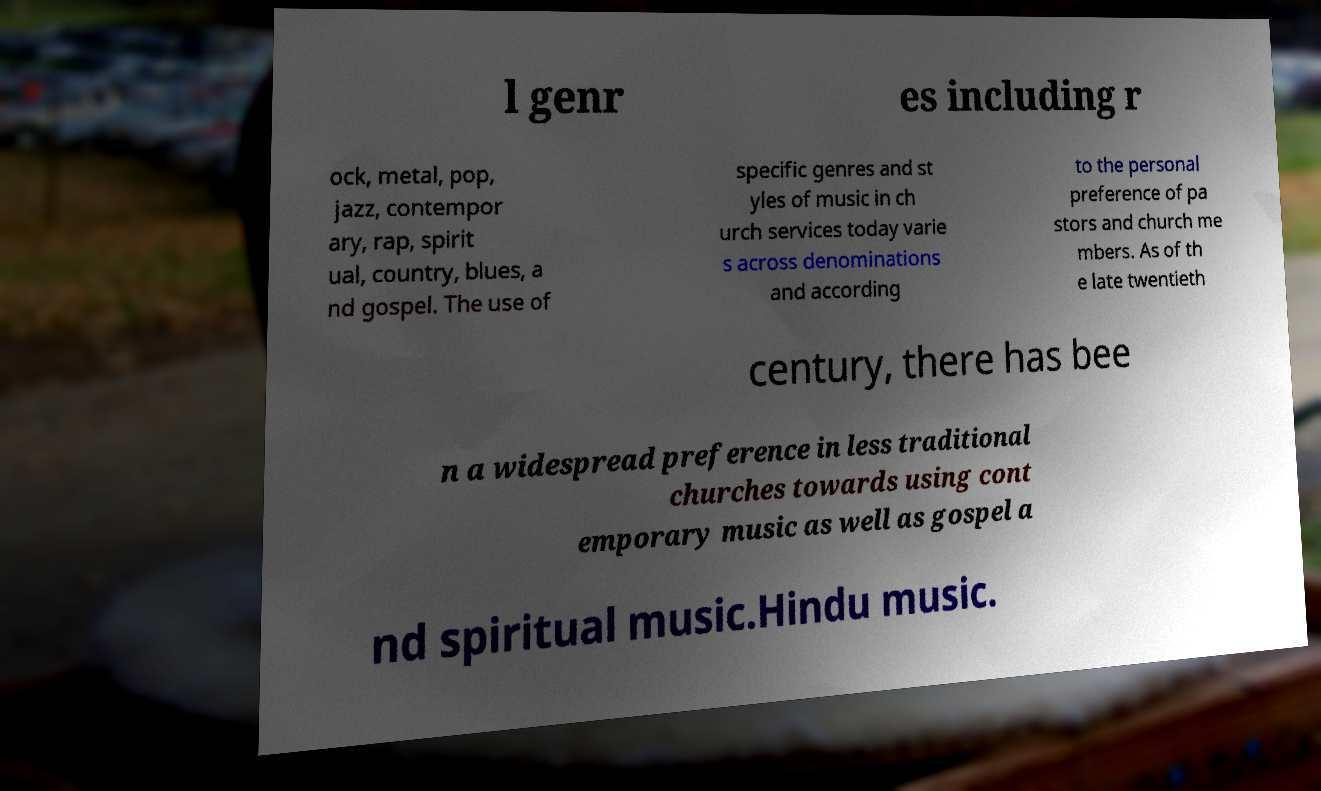Could you extract and type out the text from this image? l genr es including r ock, metal, pop, jazz, contempor ary, rap, spirit ual, country, blues, a nd gospel. The use of specific genres and st yles of music in ch urch services today varie s across denominations and according to the personal preference of pa stors and church me mbers. As of th e late twentieth century, there has bee n a widespread preference in less traditional churches towards using cont emporary music as well as gospel a nd spiritual music.Hindu music. 